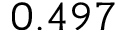<formula> <loc_0><loc_0><loc_500><loc_500>0 . 4 9 7</formula> 